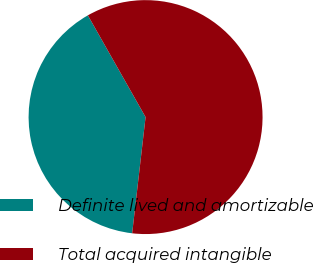Convert chart to OTSL. <chart><loc_0><loc_0><loc_500><loc_500><pie_chart><fcel>Definite lived and amortizable<fcel>Total acquired intangible<nl><fcel>39.96%<fcel>60.04%<nl></chart> 